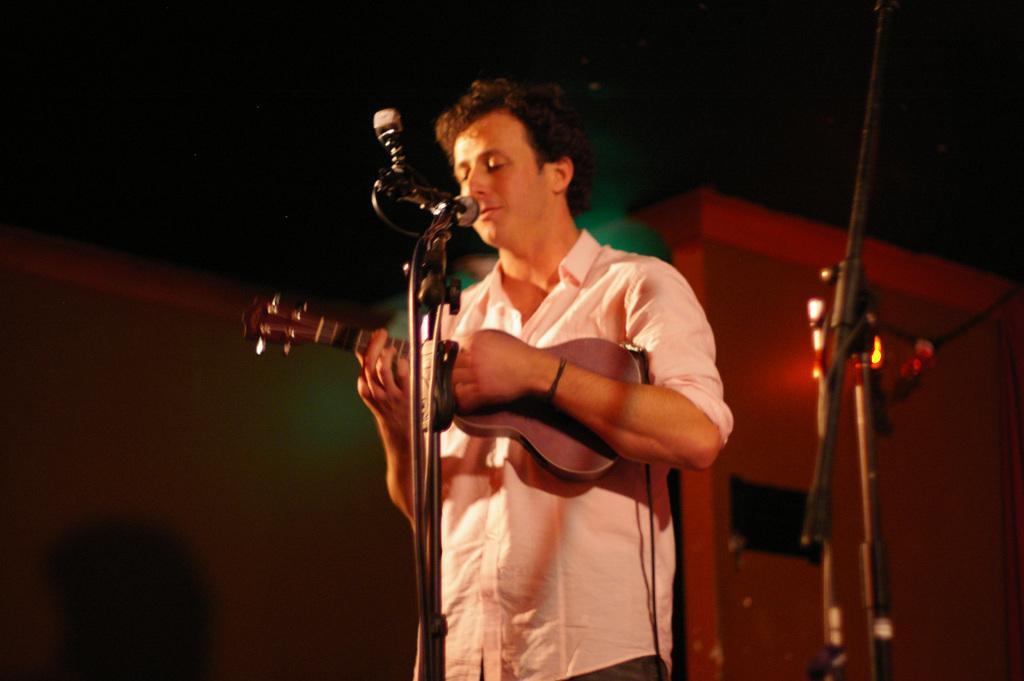Can you describe this image briefly? This picture shows a man playing guitar and singing with the help of a microphone 